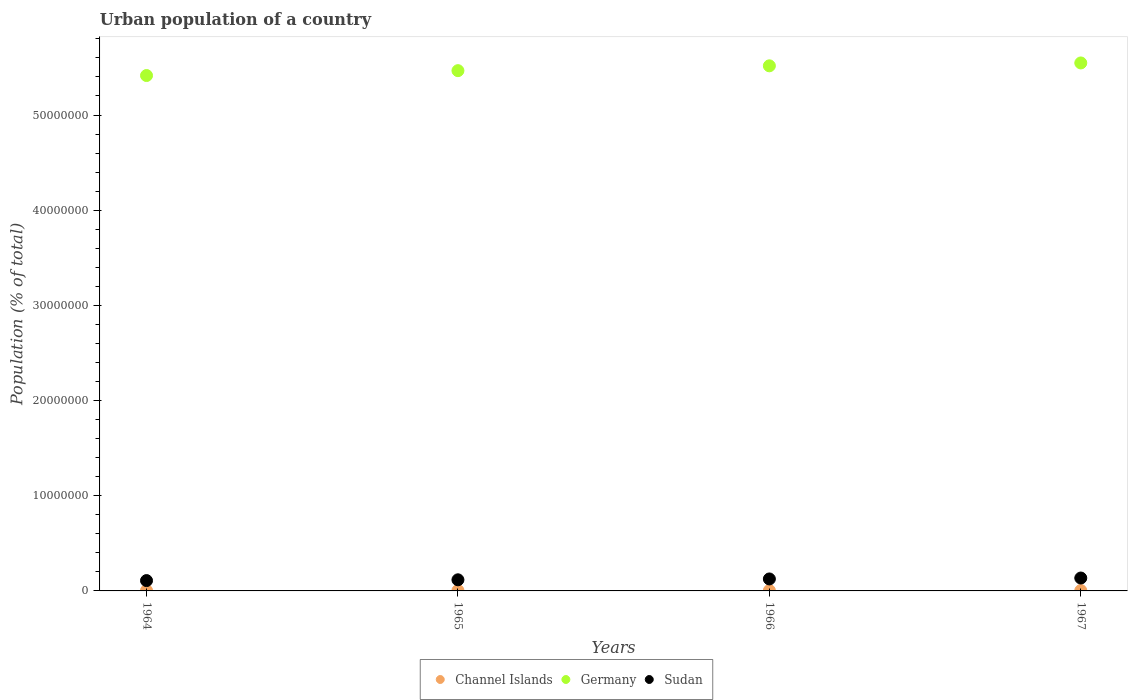Is the number of dotlines equal to the number of legend labels?
Your response must be concise. Yes. What is the urban population in Germany in 1964?
Provide a succinct answer. 5.41e+07. Across all years, what is the maximum urban population in Sudan?
Give a very brief answer. 1.35e+06. Across all years, what is the minimum urban population in Channel Islands?
Provide a short and direct response. 4.28e+04. In which year was the urban population in Sudan maximum?
Offer a terse response. 1967. In which year was the urban population in Sudan minimum?
Your response must be concise. 1964. What is the total urban population in Germany in the graph?
Make the answer very short. 2.19e+08. What is the difference between the urban population in Germany in 1964 and that in 1966?
Ensure brevity in your answer.  -1.02e+06. What is the difference between the urban population in Sudan in 1966 and the urban population in Germany in 1964?
Give a very brief answer. -5.29e+07. What is the average urban population in Channel Islands per year?
Ensure brevity in your answer.  4.31e+04. In the year 1965, what is the difference between the urban population in Sudan and urban population in Channel Islands?
Provide a short and direct response. 1.13e+06. In how many years, is the urban population in Channel Islands greater than 14000000 %?
Your answer should be compact. 0. What is the ratio of the urban population in Channel Islands in 1964 to that in 1967?
Your response must be concise. 0.99. Is the urban population in Germany in 1964 less than that in 1967?
Offer a very short reply. Yes. What is the difference between the highest and the second highest urban population in Germany?
Make the answer very short. 3.02e+05. What is the difference between the highest and the lowest urban population in Sudan?
Ensure brevity in your answer.  2.69e+05. In how many years, is the urban population in Germany greater than the average urban population in Germany taken over all years?
Provide a succinct answer. 2. Is the urban population in Channel Islands strictly greater than the urban population in Germany over the years?
Offer a very short reply. No. What is the difference between two consecutive major ticks on the Y-axis?
Your answer should be compact. 1.00e+07. Does the graph contain any zero values?
Your answer should be compact. No. Does the graph contain grids?
Provide a succinct answer. No. How are the legend labels stacked?
Provide a short and direct response. Horizontal. What is the title of the graph?
Provide a succinct answer. Urban population of a country. What is the label or title of the Y-axis?
Your answer should be compact. Population (% of total). What is the Population (% of total) of Channel Islands in 1964?
Your response must be concise. 4.28e+04. What is the Population (% of total) of Germany in 1964?
Make the answer very short. 5.41e+07. What is the Population (% of total) of Sudan in 1964?
Offer a terse response. 1.09e+06. What is the Population (% of total) of Channel Islands in 1965?
Keep it short and to the point. 4.30e+04. What is the Population (% of total) in Germany in 1965?
Give a very brief answer. 5.47e+07. What is the Population (% of total) in Sudan in 1965?
Your response must be concise. 1.17e+06. What is the Population (% of total) in Channel Islands in 1966?
Your answer should be very brief. 4.31e+04. What is the Population (% of total) of Germany in 1966?
Your response must be concise. 5.52e+07. What is the Population (% of total) in Sudan in 1966?
Provide a succinct answer. 1.26e+06. What is the Population (% of total) in Channel Islands in 1967?
Offer a terse response. 4.33e+04. What is the Population (% of total) in Germany in 1967?
Provide a short and direct response. 5.55e+07. What is the Population (% of total) of Sudan in 1967?
Give a very brief answer. 1.35e+06. Across all years, what is the maximum Population (% of total) of Channel Islands?
Your answer should be compact. 4.33e+04. Across all years, what is the maximum Population (% of total) in Germany?
Your answer should be very brief. 5.55e+07. Across all years, what is the maximum Population (% of total) of Sudan?
Offer a very short reply. 1.35e+06. Across all years, what is the minimum Population (% of total) of Channel Islands?
Offer a terse response. 4.28e+04. Across all years, what is the minimum Population (% of total) in Germany?
Ensure brevity in your answer.  5.41e+07. Across all years, what is the minimum Population (% of total) in Sudan?
Offer a very short reply. 1.09e+06. What is the total Population (% of total) of Channel Islands in the graph?
Ensure brevity in your answer.  1.72e+05. What is the total Population (% of total) in Germany in the graph?
Keep it short and to the point. 2.19e+08. What is the total Population (% of total) of Sudan in the graph?
Give a very brief answer. 4.87e+06. What is the difference between the Population (% of total) in Channel Islands in 1964 and that in 1965?
Keep it short and to the point. -157. What is the difference between the Population (% of total) of Germany in 1964 and that in 1965?
Ensure brevity in your answer.  -5.13e+05. What is the difference between the Population (% of total) of Sudan in 1964 and that in 1965?
Make the answer very short. -8.31e+04. What is the difference between the Population (% of total) in Channel Islands in 1964 and that in 1966?
Give a very brief answer. -315. What is the difference between the Population (% of total) of Germany in 1964 and that in 1966?
Provide a short and direct response. -1.02e+06. What is the difference between the Population (% of total) in Sudan in 1964 and that in 1966?
Offer a very short reply. -1.73e+05. What is the difference between the Population (% of total) of Channel Islands in 1964 and that in 1967?
Your response must be concise. -473. What is the difference between the Population (% of total) in Germany in 1964 and that in 1967?
Keep it short and to the point. -1.32e+06. What is the difference between the Population (% of total) in Sudan in 1964 and that in 1967?
Provide a succinct answer. -2.69e+05. What is the difference between the Population (% of total) of Channel Islands in 1965 and that in 1966?
Your answer should be compact. -158. What is the difference between the Population (% of total) in Germany in 1965 and that in 1966?
Your answer should be very brief. -5.07e+05. What is the difference between the Population (% of total) in Sudan in 1965 and that in 1966?
Your answer should be compact. -8.95e+04. What is the difference between the Population (% of total) of Channel Islands in 1965 and that in 1967?
Keep it short and to the point. -316. What is the difference between the Population (% of total) in Germany in 1965 and that in 1967?
Give a very brief answer. -8.09e+05. What is the difference between the Population (% of total) in Sudan in 1965 and that in 1967?
Your answer should be compact. -1.86e+05. What is the difference between the Population (% of total) in Channel Islands in 1966 and that in 1967?
Provide a succinct answer. -158. What is the difference between the Population (% of total) in Germany in 1966 and that in 1967?
Provide a succinct answer. -3.02e+05. What is the difference between the Population (% of total) in Sudan in 1966 and that in 1967?
Ensure brevity in your answer.  -9.65e+04. What is the difference between the Population (% of total) in Channel Islands in 1964 and the Population (% of total) in Germany in 1965?
Provide a succinct answer. -5.46e+07. What is the difference between the Population (% of total) in Channel Islands in 1964 and the Population (% of total) in Sudan in 1965?
Keep it short and to the point. -1.13e+06. What is the difference between the Population (% of total) of Germany in 1964 and the Population (% of total) of Sudan in 1965?
Keep it short and to the point. 5.30e+07. What is the difference between the Population (% of total) in Channel Islands in 1964 and the Population (% of total) in Germany in 1966?
Keep it short and to the point. -5.51e+07. What is the difference between the Population (% of total) in Channel Islands in 1964 and the Population (% of total) in Sudan in 1966?
Offer a terse response. -1.22e+06. What is the difference between the Population (% of total) in Germany in 1964 and the Population (% of total) in Sudan in 1966?
Your answer should be very brief. 5.29e+07. What is the difference between the Population (% of total) of Channel Islands in 1964 and the Population (% of total) of Germany in 1967?
Your answer should be compact. -5.54e+07. What is the difference between the Population (% of total) in Channel Islands in 1964 and the Population (% of total) in Sudan in 1967?
Provide a short and direct response. -1.31e+06. What is the difference between the Population (% of total) of Germany in 1964 and the Population (% of total) of Sudan in 1967?
Keep it short and to the point. 5.28e+07. What is the difference between the Population (% of total) in Channel Islands in 1965 and the Population (% of total) in Germany in 1966?
Your answer should be very brief. -5.51e+07. What is the difference between the Population (% of total) in Channel Islands in 1965 and the Population (% of total) in Sudan in 1966?
Provide a short and direct response. -1.22e+06. What is the difference between the Population (% of total) in Germany in 1965 and the Population (% of total) in Sudan in 1966?
Offer a terse response. 5.34e+07. What is the difference between the Population (% of total) in Channel Islands in 1965 and the Population (% of total) in Germany in 1967?
Keep it short and to the point. -5.54e+07. What is the difference between the Population (% of total) in Channel Islands in 1965 and the Population (% of total) in Sudan in 1967?
Keep it short and to the point. -1.31e+06. What is the difference between the Population (% of total) of Germany in 1965 and the Population (% of total) of Sudan in 1967?
Your answer should be very brief. 5.33e+07. What is the difference between the Population (% of total) of Channel Islands in 1966 and the Population (% of total) of Germany in 1967?
Offer a terse response. -5.54e+07. What is the difference between the Population (% of total) in Channel Islands in 1966 and the Population (% of total) in Sudan in 1967?
Offer a very short reply. -1.31e+06. What is the difference between the Population (% of total) in Germany in 1966 and the Population (% of total) in Sudan in 1967?
Offer a very short reply. 5.38e+07. What is the average Population (% of total) of Channel Islands per year?
Offer a terse response. 4.31e+04. What is the average Population (% of total) in Germany per year?
Your answer should be very brief. 5.49e+07. What is the average Population (% of total) of Sudan per year?
Keep it short and to the point. 1.22e+06. In the year 1964, what is the difference between the Population (% of total) of Channel Islands and Population (% of total) of Germany?
Provide a succinct answer. -5.41e+07. In the year 1964, what is the difference between the Population (% of total) of Channel Islands and Population (% of total) of Sudan?
Provide a short and direct response. -1.04e+06. In the year 1964, what is the difference between the Population (% of total) in Germany and Population (% of total) in Sudan?
Offer a very short reply. 5.31e+07. In the year 1965, what is the difference between the Population (% of total) of Channel Islands and Population (% of total) of Germany?
Offer a terse response. -5.46e+07. In the year 1965, what is the difference between the Population (% of total) in Channel Islands and Population (% of total) in Sudan?
Make the answer very short. -1.13e+06. In the year 1965, what is the difference between the Population (% of total) in Germany and Population (% of total) in Sudan?
Make the answer very short. 5.35e+07. In the year 1966, what is the difference between the Population (% of total) in Channel Islands and Population (% of total) in Germany?
Provide a succinct answer. -5.51e+07. In the year 1966, what is the difference between the Population (% of total) of Channel Islands and Population (% of total) of Sudan?
Your answer should be compact. -1.21e+06. In the year 1966, what is the difference between the Population (% of total) of Germany and Population (% of total) of Sudan?
Your answer should be very brief. 5.39e+07. In the year 1967, what is the difference between the Population (% of total) of Channel Islands and Population (% of total) of Germany?
Offer a very short reply. -5.54e+07. In the year 1967, what is the difference between the Population (% of total) of Channel Islands and Population (% of total) of Sudan?
Offer a very short reply. -1.31e+06. In the year 1967, what is the difference between the Population (% of total) of Germany and Population (% of total) of Sudan?
Your answer should be very brief. 5.41e+07. What is the ratio of the Population (% of total) in Channel Islands in 1964 to that in 1965?
Your response must be concise. 1. What is the ratio of the Population (% of total) in Germany in 1964 to that in 1965?
Make the answer very short. 0.99. What is the ratio of the Population (% of total) in Sudan in 1964 to that in 1965?
Your answer should be very brief. 0.93. What is the ratio of the Population (% of total) of Germany in 1964 to that in 1966?
Offer a terse response. 0.98. What is the ratio of the Population (% of total) in Sudan in 1964 to that in 1966?
Your answer should be very brief. 0.86. What is the ratio of the Population (% of total) in Channel Islands in 1964 to that in 1967?
Offer a terse response. 0.99. What is the ratio of the Population (% of total) of Germany in 1964 to that in 1967?
Give a very brief answer. 0.98. What is the ratio of the Population (% of total) in Sudan in 1964 to that in 1967?
Keep it short and to the point. 0.8. What is the ratio of the Population (% of total) in Sudan in 1965 to that in 1966?
Make the answer very short. 0.93. What is the ratio of the Population (% of total) in Germany in 1965 to that in 1967?
Make the answer very short. 0.99. What is the ratio of the Population (% of total) in Sudan in 1965 to that in 1967?
Make the answer very short. 0.86. What is the ratio of the Population (% of total) of Channel Islands in 1966 to that in 1967?
Provide a short and direct response. 1. What is the ratio of the Population (% of total) of Sudan in 1966 to that in 1967?
Make the answer very short. 0.93. What is the difference between the highest and the second highest Population (% of total) of Channel Islands?
Your answer should be compact. 158. What is the difference between the highest and the second highest Population (% of total) of Germany?
Your answer should be compact. 3.02e+05. What is the difference between the highest and the second highest Population (% of total) in Sudan?
Make the answer very short. 9.65e+04. What is the difference between the highest and the lowest Population (% of total) of Channel Islands?
Your answer should be compact. 473. What is the difference between the highest and the lowest Population (% of total) of Germany?
Make the answer very short. 1.32e+06. What is the difference between the highest and the lowest Population (% of total) in Sudan?
Your response must be concise. 2.69e+05. 